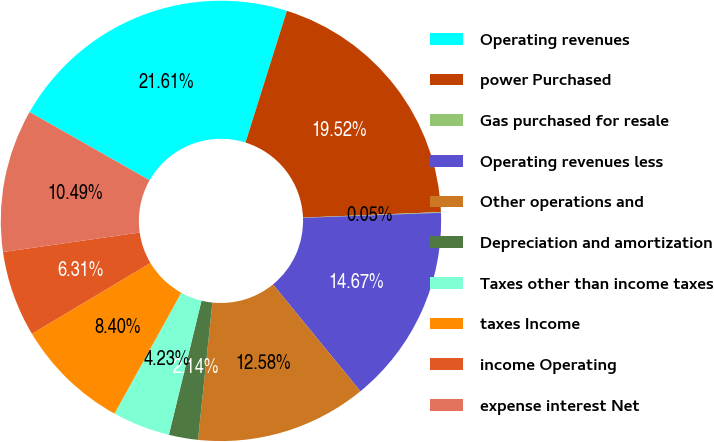Convert chart to OTSL. <chart><loc_0><loc_0><loc_500><loc_500><pie_chart><fcel>Operating revenues<fcel>power Purchased<fcel>Gas purchased for resale<fcel>Operating revenues less<fcel>Other operations and<fcel>Depreciation and amortization<fcel>Taxes other than income taxes<fcel>taxes Income<fcel>income Operating<fcel>expense interest Net<nl><fcel>21.61%<fcel>19.52%<fcel>0.05%<fcel>14.67%<fcel>12.58%<fcel>2.14%<fcel>4.23%<fcel>8.4%<fcel>6.31%<fcel>10.49%<nl></chart> 